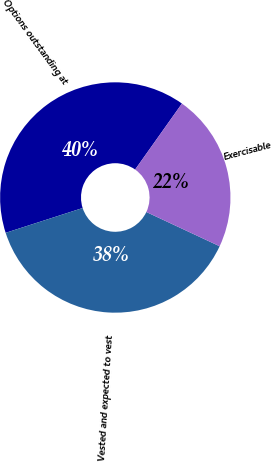Convert chart to OTSL. <chart><loc_0><loc_0><loc_500><loc_500><pie_chart><fcel>Options outstanding at<fcel>Vested and expected to vest<fcel>Exercisable<nl><fcel>39.78%<fcel>38.08%<fcel>22.13%<nl></chart> 